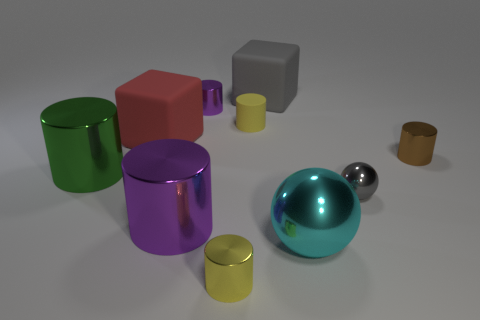What is the size of the other thing that is the same shape as the big cyan object?
Provide a short and direct response. Small. What is the shape of the small yellow object in front of the cyan ball?
Provide a short and direct response. Cylinder. Is the yellow cylinder that is behind the big red rubber cube made of the same material as the brown object that is on the right side of the red cube?
Your answer should be very brief. No. The large gray object has what shape?
Your answer should be very brief. Cube. Is the number of gray metallic objects that are behind the big gray matte block the same as the number of purple objects?
Ensure brevity in your answer.  No. The rubber object that is the same color as the tiny shiny sphere is what size?
Keep it short and to the point. Large. Is there a yellow cylinder made of the same material as the large red block?
Your answer should be very brief. Yes. Does the rubber thing that is in front of the yellow rubber thing have the same shape as the small yellow object that is in front of the cyan metal object?
Offer a terse response. No. Are there any cyan metallic balls?
Your answer should be very brief. Yes. What color is the other shiny cylinder that is the same size as the green shiny cylinder?
Give a very brief answer. Purple. 